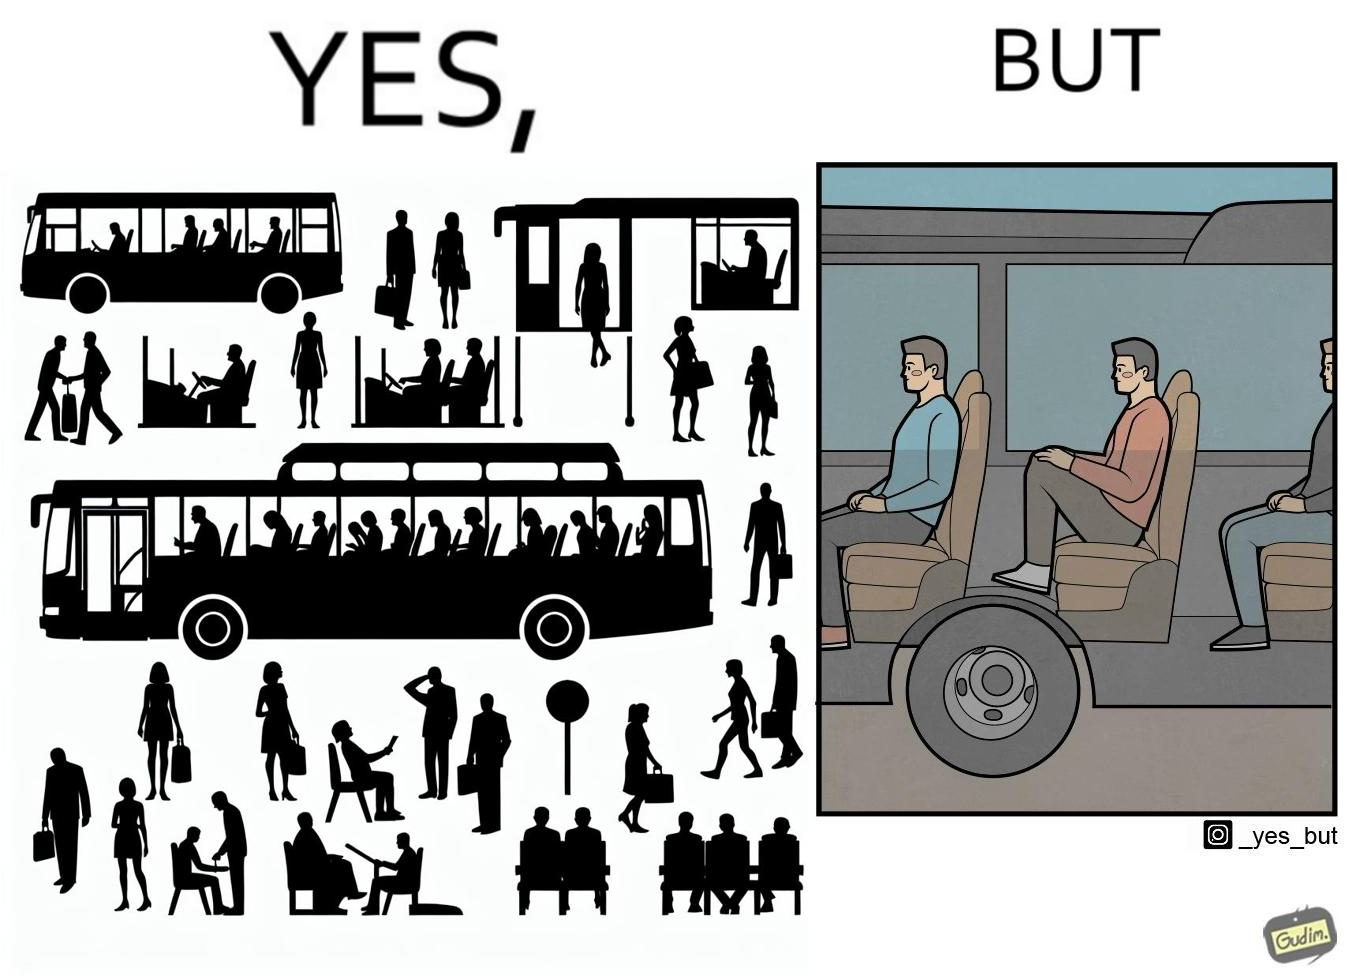What is shown in the left half versus the right half of this image? In the left part of the image: people traveling on the bus In the right part of the image: a person sitting uncomfortably on a bus 